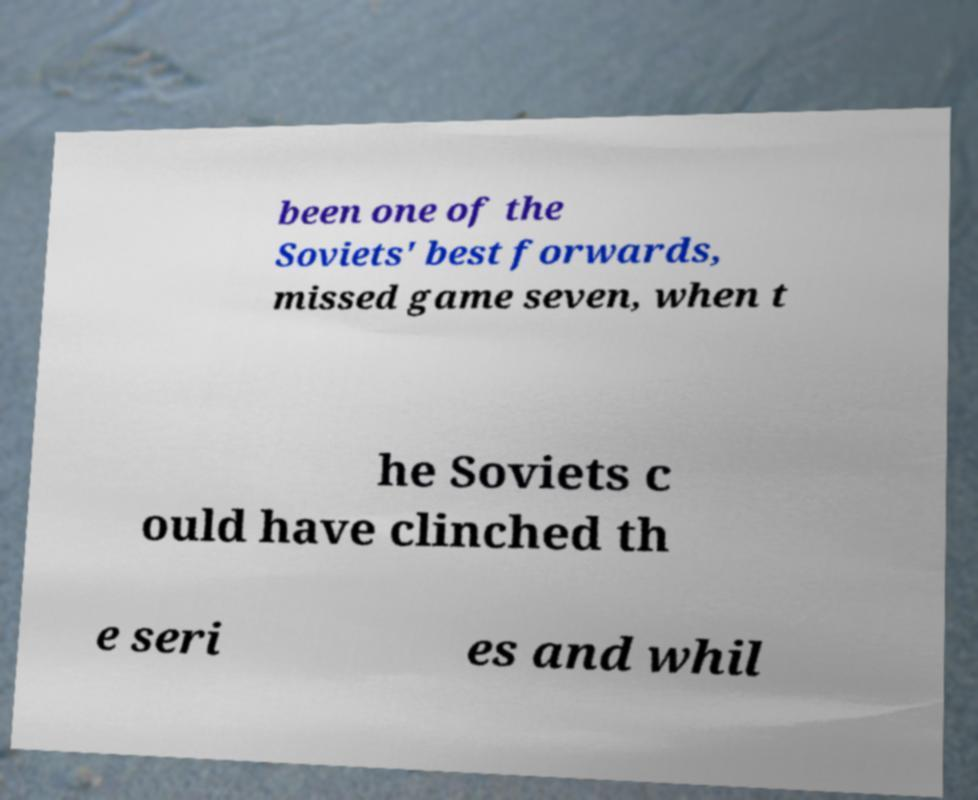Please read and relay the text visible in this image. What does it say? been one of the Soviets' best forwards, missed game seven, when t he Soviets c ould have clinched th e seri es and whil 